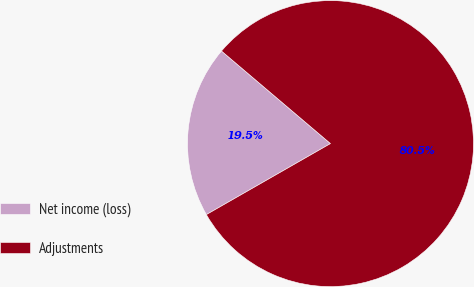Convert chart. <chart><loc_0><loc_0><loc_500><loc_500><pie_chart><fcel>Net income (loss)<fcel>Adjustments<nl><fcel>19.48%<fcel>80.52%<nl></chart> 